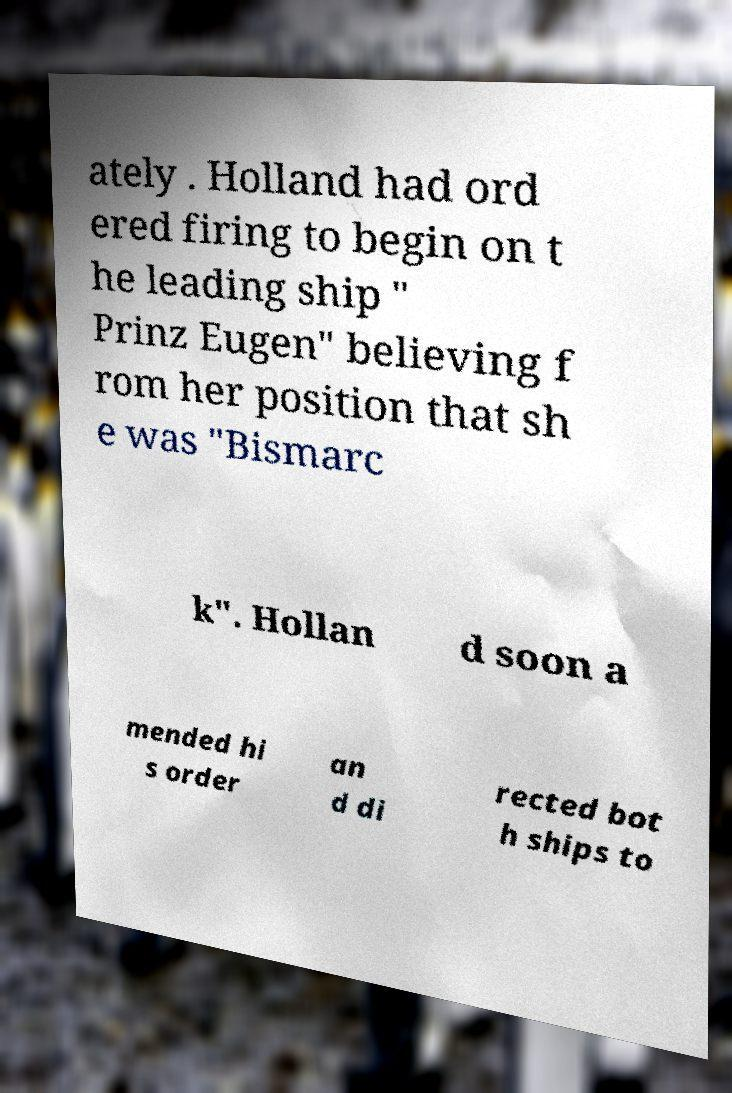There's text embedded in this image that I need extracted. Can you transcribe it verbatim? ately . Holland had ord ered firing to begin on t he leading ship " Prinz Eugen" believing f rom her position that sh e was "Bismarc k". Hollan d soon a mended hi s order an d di rected bot h ships to 